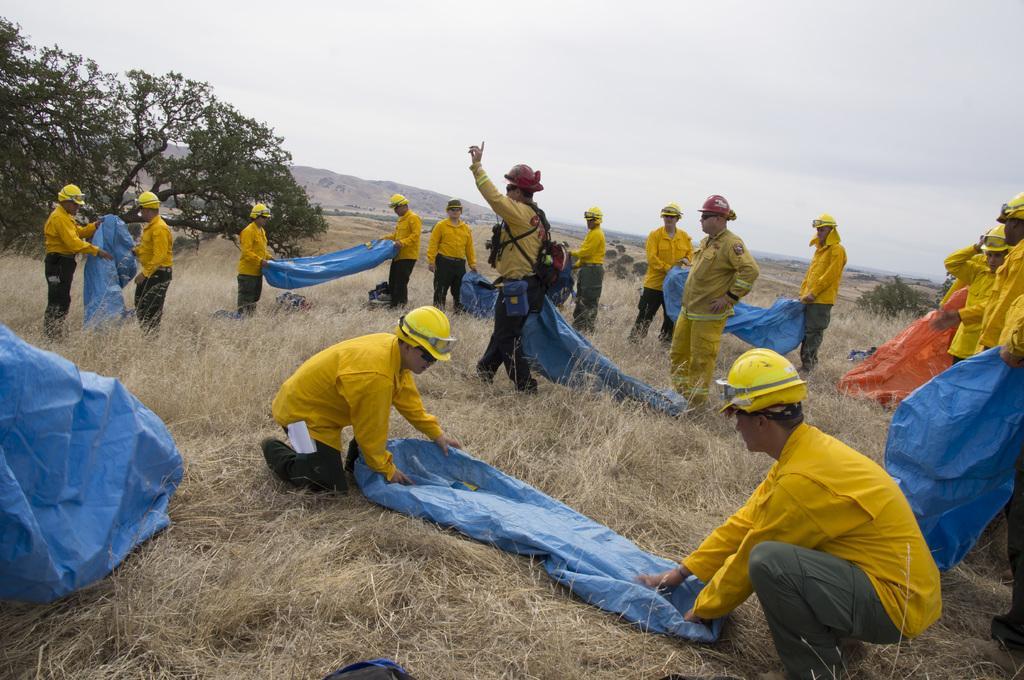How would you summarize this image in a sentence or two? This picture is clicked outside. In the center we can see the group of people holding some blue color objects and in the right corner we can see the group of people wearing yellow color dress and seems to be standing on the ground and we can see the grass. In the background we can see the sky, trees, hills and some other items and in the middle we can see a person wearing a helmet, backpack and seems to be walking on the ground. 